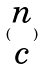Convert formula to latex. <formula><loc_0><loc_0><loc_500><loc_500>( \begin{matrix} n \\ c \end{matrix} )</formula> 